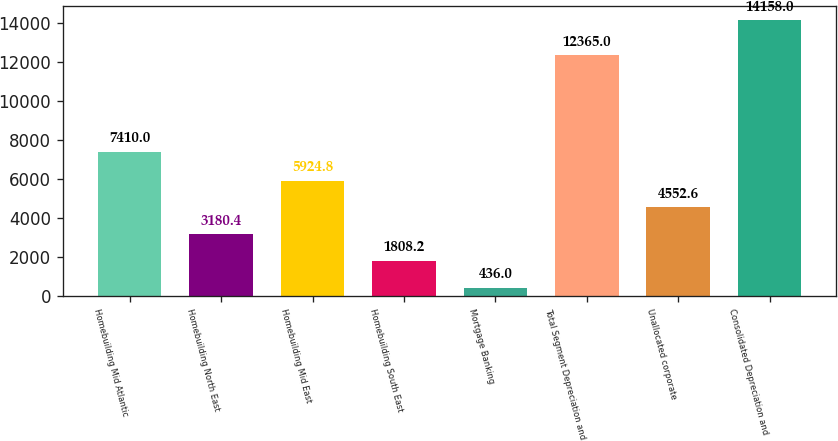Convert chart. <chart><loc_0><loc_0><loc_500><loc_500><bar_chart><fcel>Homebuilding Mid Atlantic<fcel>Homebuilding North East<fcel>Homebuilding Mid East<fcel>Homebuilding South East<fcel>Mortgage Banking<fcel>Total Segment Depreciation and<fcel>Unallocated corporate<fcel>Consolidated Depreciation and<nl><fcel>7410<fcel>3180.4<fcel>5924.8<fcel>1808.2<fcel>436<fcel>12365<fcel>4552.6<fcel>14158<nl></chart> 